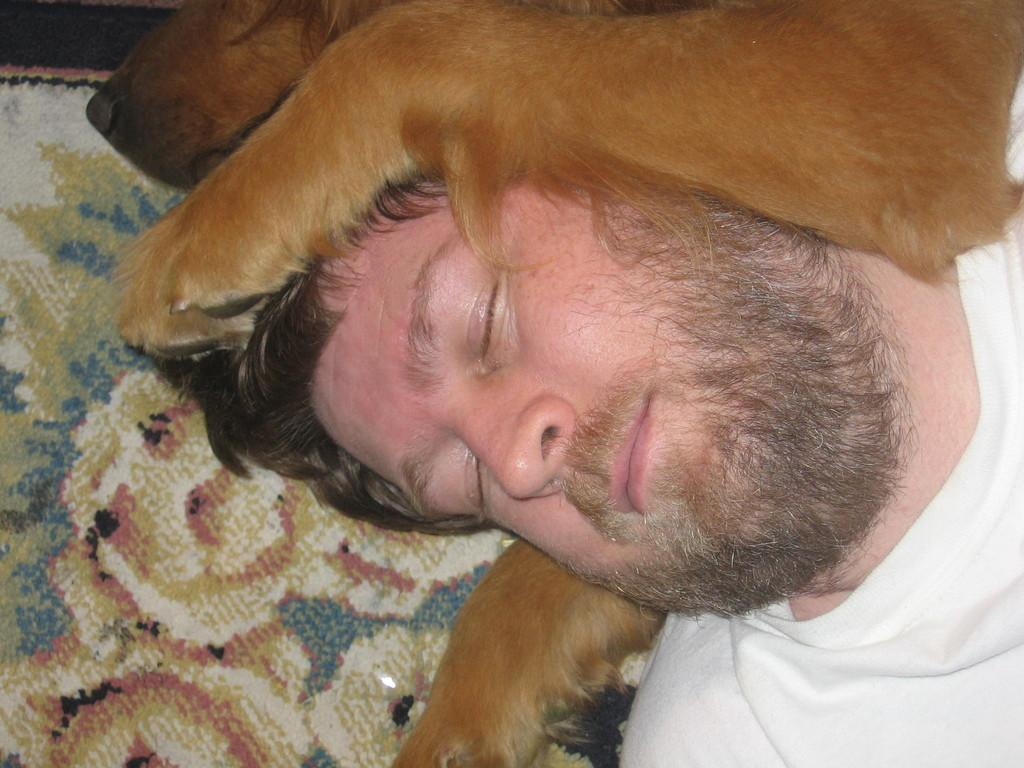Who is present in the image? There is a man in the image. What is the man doing in the image? The man is sleeping in the image. Is there any other living being present in the image? Yes, there is a dog in the image. What is the dog doing in the image? The dog is on top of the man and is also sleeping. What is beneath the man and the dog? There is a carpet beneath the man and the dog. What is the color of the dog? The dog is brown in color. What type of relation does the man have with the bottle in the image? There is no bottle present in the image, so it is not possible to determine any relation between the man and a bottle. 